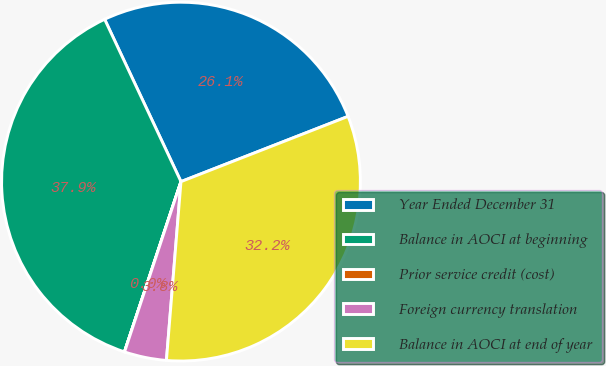Convert chart. <chart><loc_0><loc_0><loc_500><loc_500><pie_chart><fcel>Year Ended December 31<fcel>Balance in AOCI at beginning<fcel>Prior service credit (cost)<fcel>Foreign currency translation<fcel>Balance in AOCI at end of year<nl><fcel>26.07%<fcel>37.9%<fcel>0.01%<fcel>3.8%<fcel>32.22%<nl></chart> 